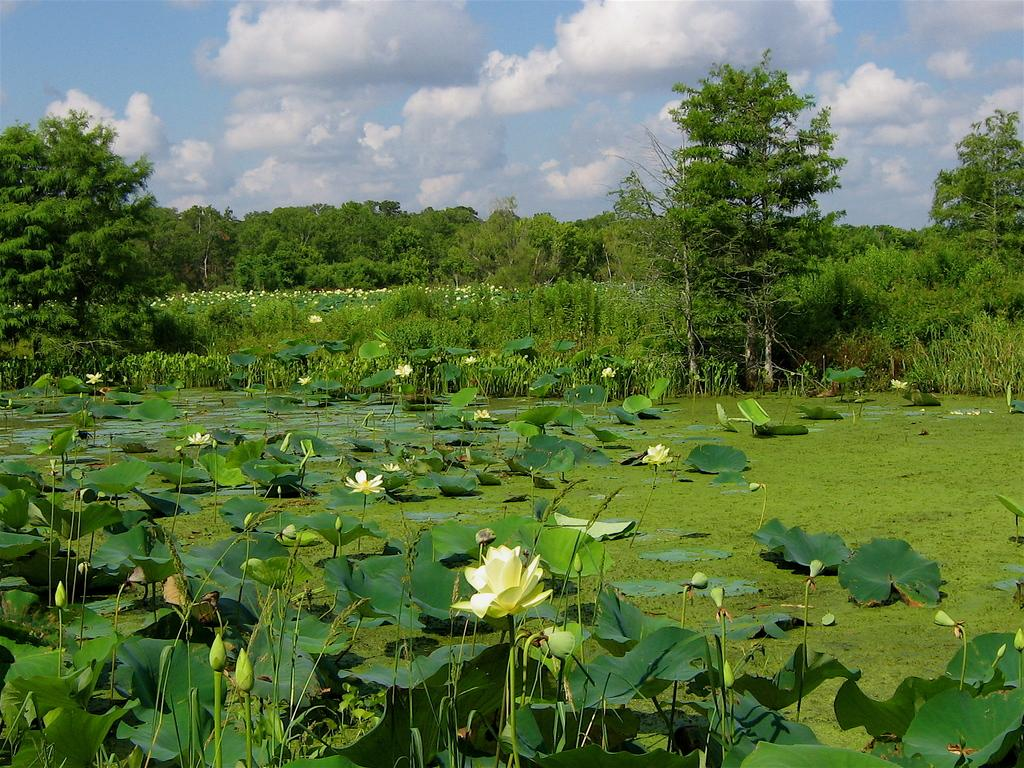What is the main feature of the image? There is a pond in the image. What can be found in the pond? The pond contains lotus flowers and lotus leaves. What is visible in the background of the image? There are trees and the sky in the background of the image. How many rabbits are riding bikes around the pond in the image? There are no rabbits or bikes present in the image; it features a pond with lotus flowers and lotus leaves. 